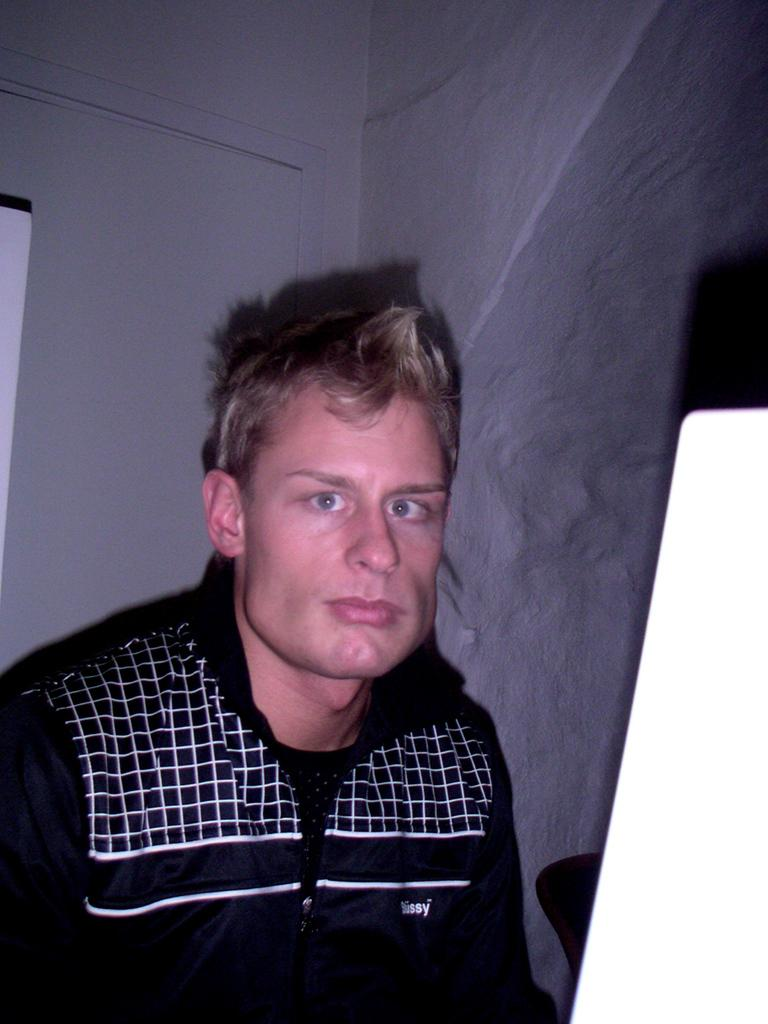Who is present in the image? There is a man in the image. What can be seen in the background of the image? There is a wall in the background of the image. What type of bed is visible in the image? There is no bed present in the image; it only features a man and a wall in the background. 